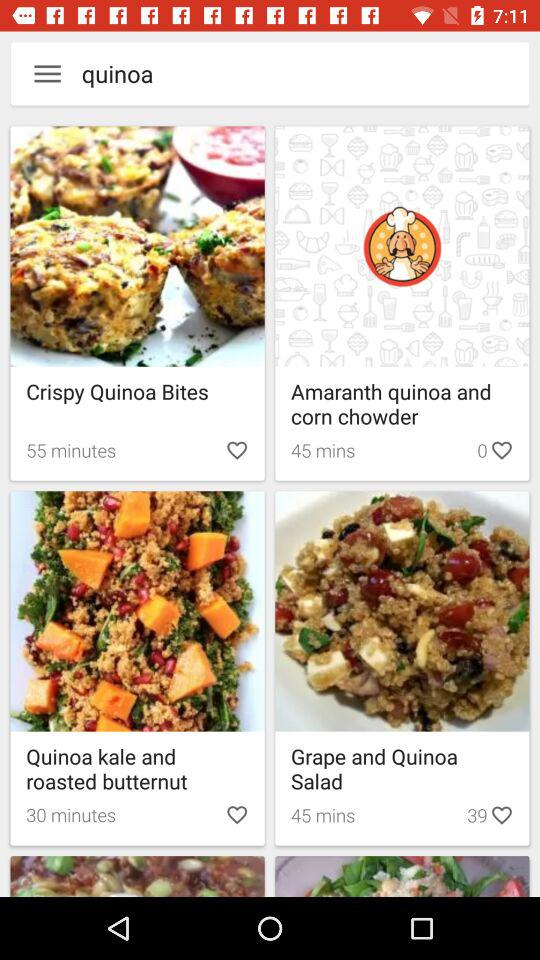How long will it take to prepare Grape and Quinoa Salad?
When the provided information is insufficient, respond with <no answer>. <no answer> 